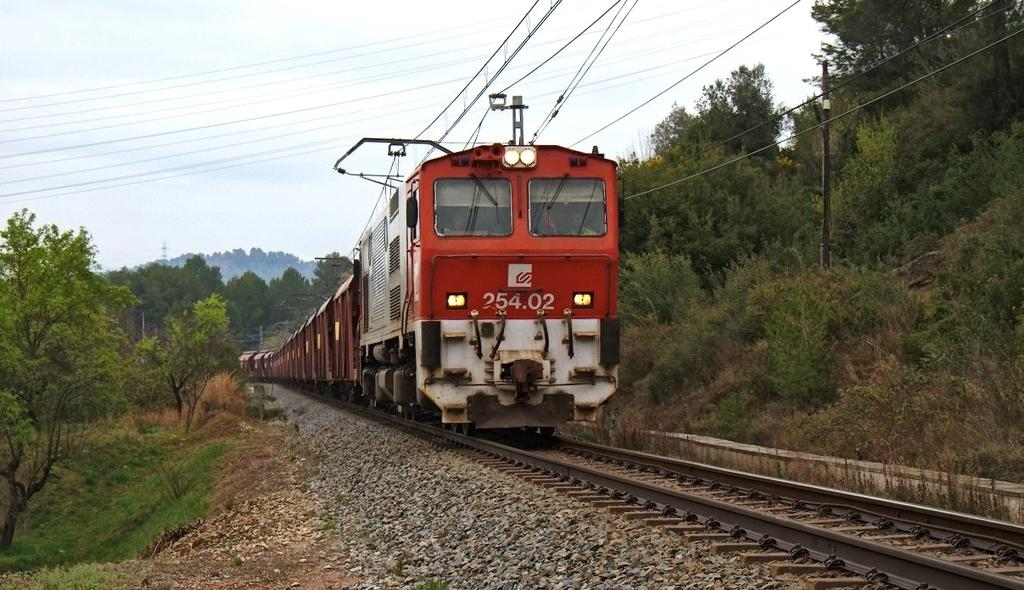What is the main subject of the image? There is a train on the track in the image. What can be seen in the background of the image? There are trees, hills, wires, and the sky visible in the background of the image. Can you describe any structures or objects in the image? There is a pole in the image. What type of harbor can be seen in the image? There is no harbor present in the image; it features a train on a track with a background of trees, hills, wires, and the sky. What suggestion does the train provide to the viewer in the image? The train does not provide any suggestions to the viewer in the image; it is simply a subject in the photograph. 